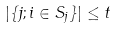<formula> <loc_0><loc_0><loc_500><loc_500>| \{ j ; i \in S _ { j } \} | \leq t</formula> 